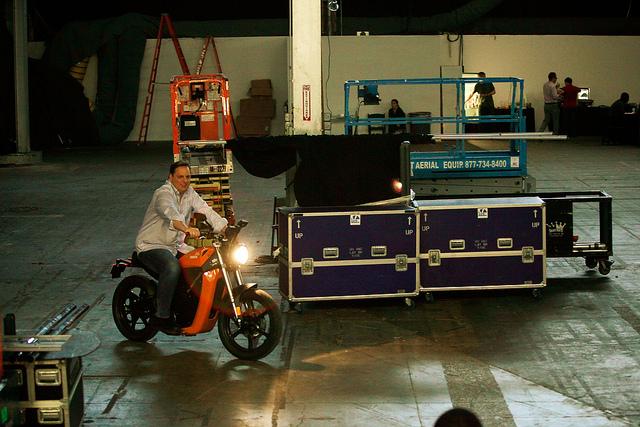What is the man riding?
Keep it brief. Motorcycle. How many people are in the background?
Short answer required. 5. How many people are wearing blue?
Be succinct. 0. How many trunks are near the man?
Answer briefly. 2. 